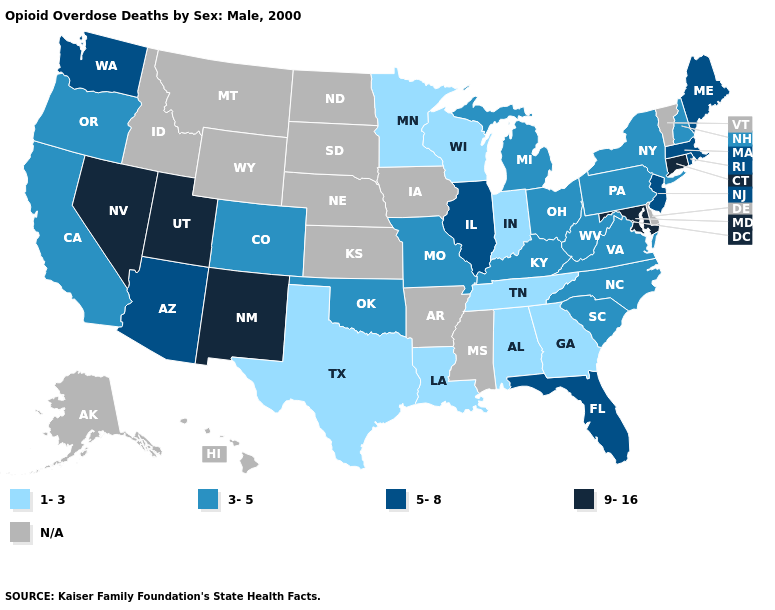What is the value of Connecticut?
Short answer required. 9-16. Which states have the highest value in the USA?
Concise answer only. Connecticut, Maryland, Nevada, New Mexico, Utah. Does the first symbol in the legend represent the smallest category?
Answer briefly. Yes. What is the value of New York?
Write a very short answer. 3-5. Which states hav the highest value in the West?
Be succinct. Nevada, New Mexico, Utah. Name the states that have a value in the range N/A?
Answer briefly. Alaska, Arkansas, Delaware, Hawaii, Idaho, Iowa, Kansas, Mississippi, Montana, Nebraska, North Dakota, South Dakota, Vermont, Wyoming. Among the states that border Kansas , which have the lowest value?
Short answer required. Colorado, Missouri, Oklahoma. What is the value of Michigan?
Be succinct. 3-5. What is the highest value in states that border California?
Quick response, please. 9-16. Name the states that have a value in the range 1-3?
Concise answer only. Alabama, Georgia, Indiana, Louisiana, Minnesota, Tennessee, Texas, Wisconsin. What is the highest value in states that border Washington?
Concise answer only. 3-5. Name the states that have a value in the range 1-3?
Give a very brief answer. Alabama, Georgia, Indiana, Louisiana, Minnesota, Tennessee, Texas, Wisconsin. Name the states that have a value in the range N/A?
Concise answer only. Alaska, Arkansas, Delaware, Hawaii, Idaho, Iowa, Kansas, Mississippi, Montana, Nebraska, North Dakota, South Dakota, Vermont, Wyoming. What is the lowest value in the USA?
Answer briefly. 1-3. 